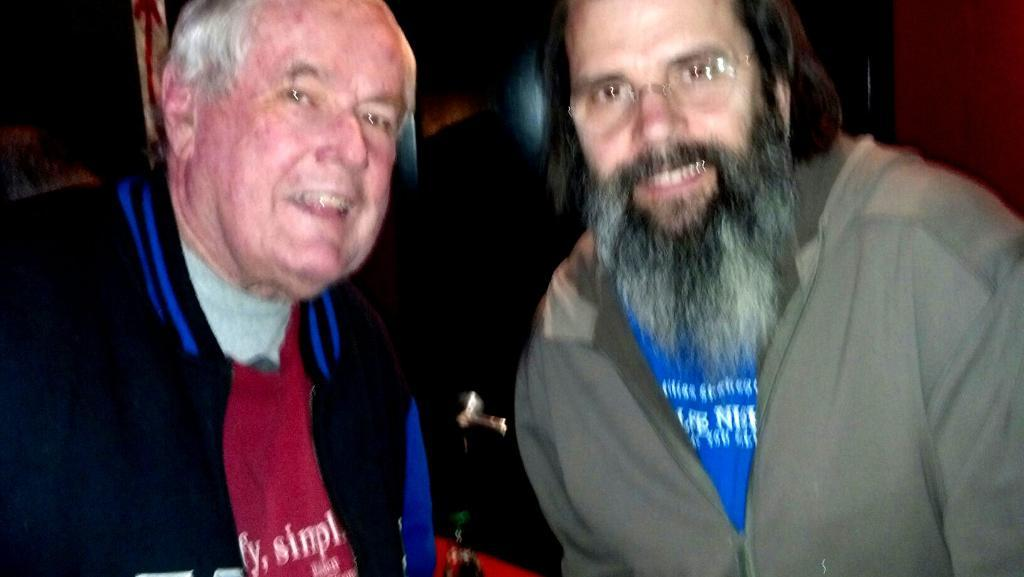How many people are present in the image? There are two men in the image. What type of paste is being used by the men in the image? There is no paste present in the image; it only features two men. 